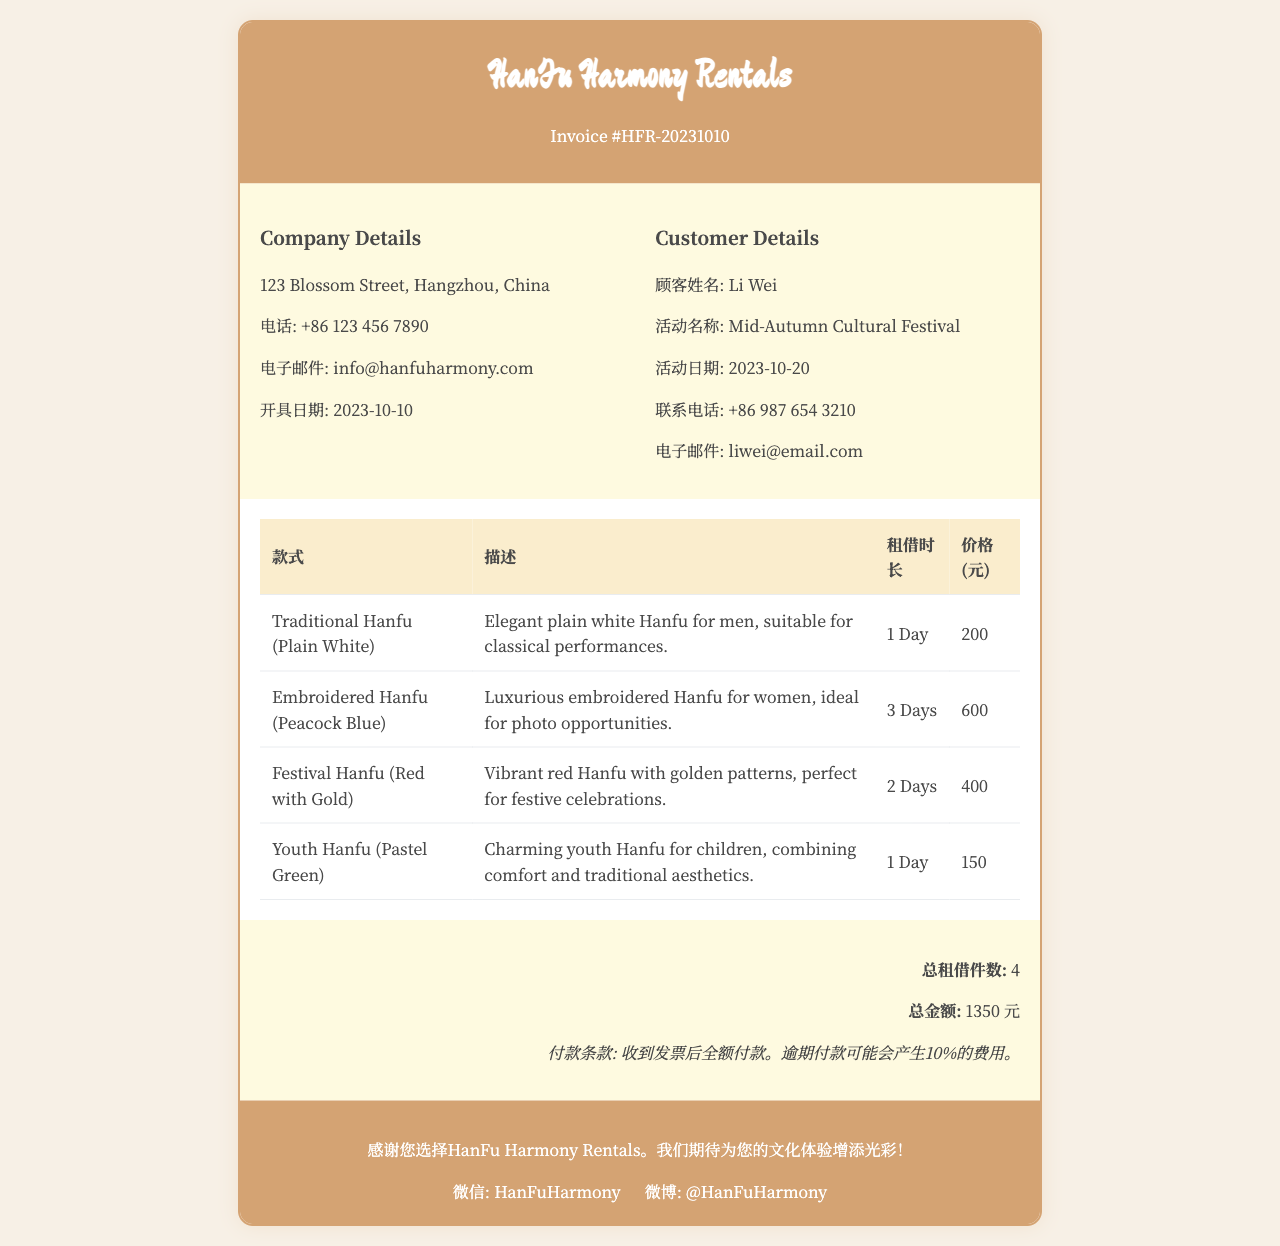What is the invoice number? The invoice number is listed prominently in the header section of the document.
Answer: HFR-20231010 What is the company address? The company address is mentioned in the company details section.
Answer: 123 Blossom Street, Hangzhou, China How many styles of Hanfu are listed? The document provides a table with different styles of Hanfu, and we can count them to find the total.
Answer: 4 What is the total amount due? The total amount is provided in the summary section of the invoice.
Answer: 1350 元 What is the rental duration for the Embroidered Hanfu (Peacock Blue)? The rental duration can be found in the table under the duration column for that specific Hanfu style.
Answer: 3 Days What is the phone number of HanFu Harmony Rentals? The phone number is included in the company details section.
Answer: +86 123 456 7890 What is the payment term stated in the invoice? The payment term is explicitly mentioned in the summary section of the invoice.
Answer: 收到发票后全额付款 Who is the customer for this invoice? The customer's name is provided in the customer details section.
Answer: Li Wei What style of Hanfu has the highest rental price? By comparing the prices listed for each Hanfu style in the table, we determine which one is the most expensive.
Answer: Embroidered Hanfu (Peacock Blue) 